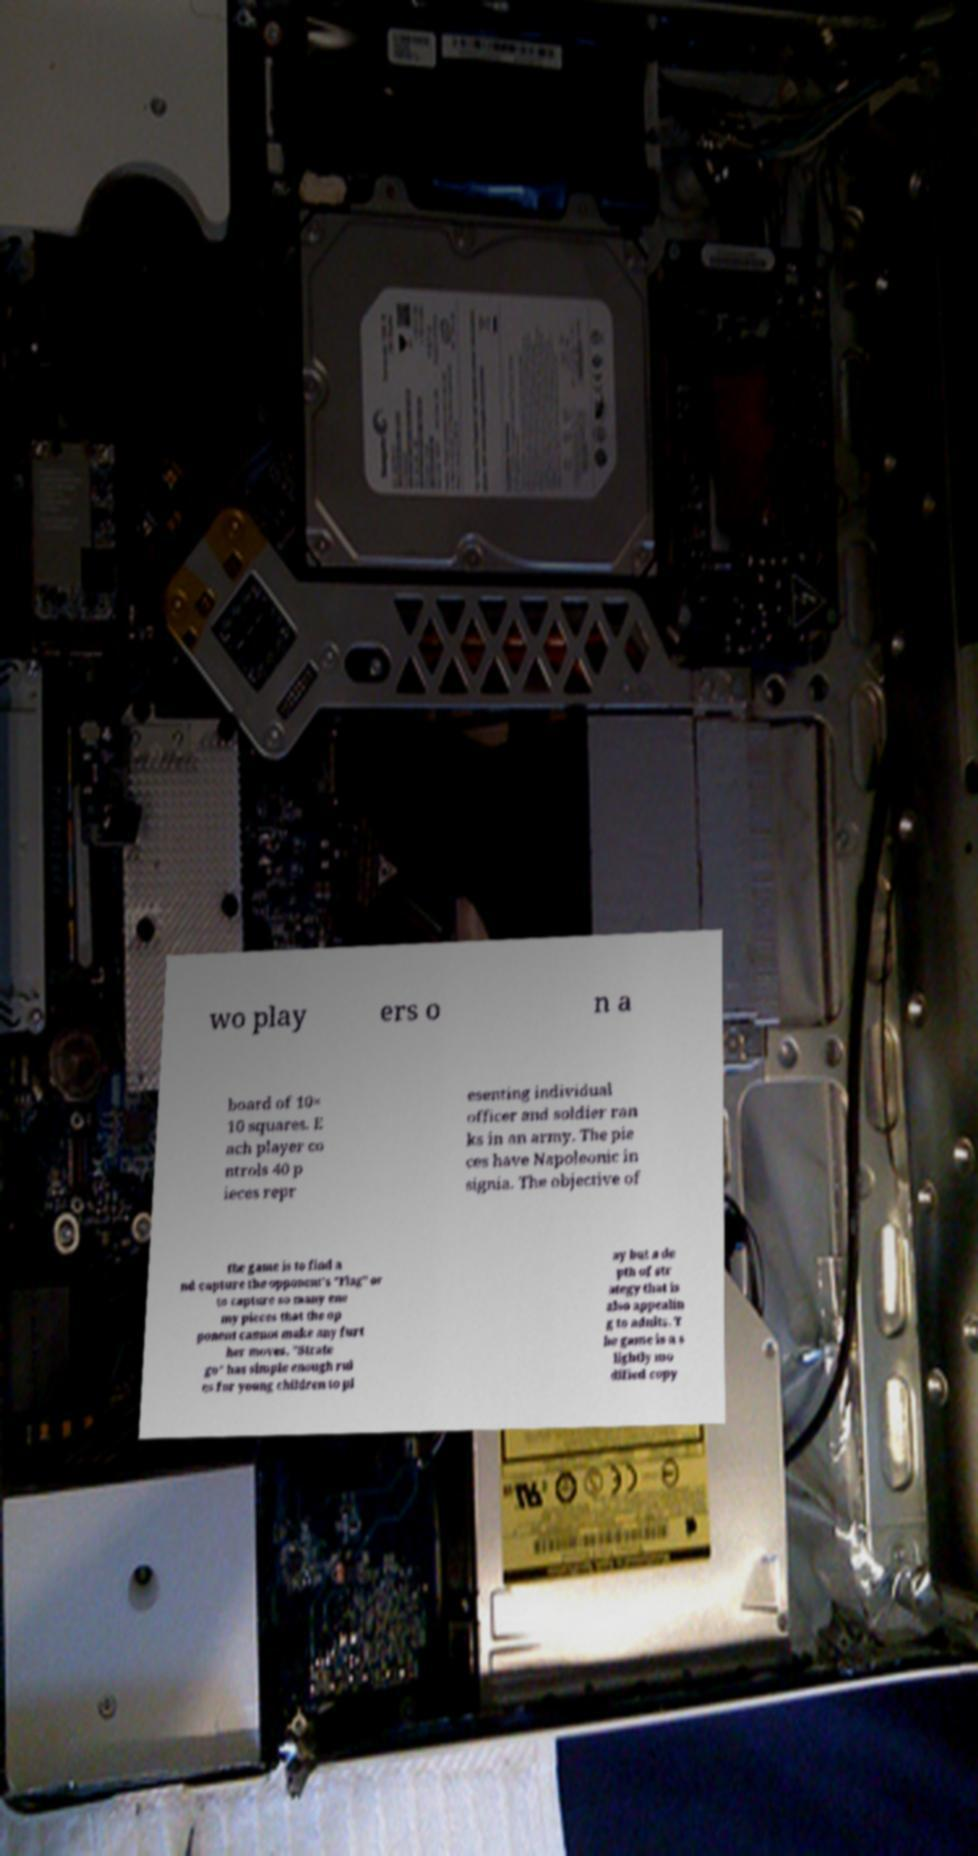What messages or text are displayed in this image? I need them in a readable, typed format. wo play ers o n a board of 10× 10 squares. E ach player co ntrols 40 p ieces repr esenting individual officer and soldier ran ks in an army. The pie ces have Napoleonic in signia. The objective of the game is to find a nd capture the opponent's "Flag" or to capture so many ene my pieces that the op ponent cannot make any furt her moves. "Strate go" has simple enough rul es for young children to pl ay but a de pth of str ategy that is also appealin g to adults. T he game is a s lightly mo dified copy 